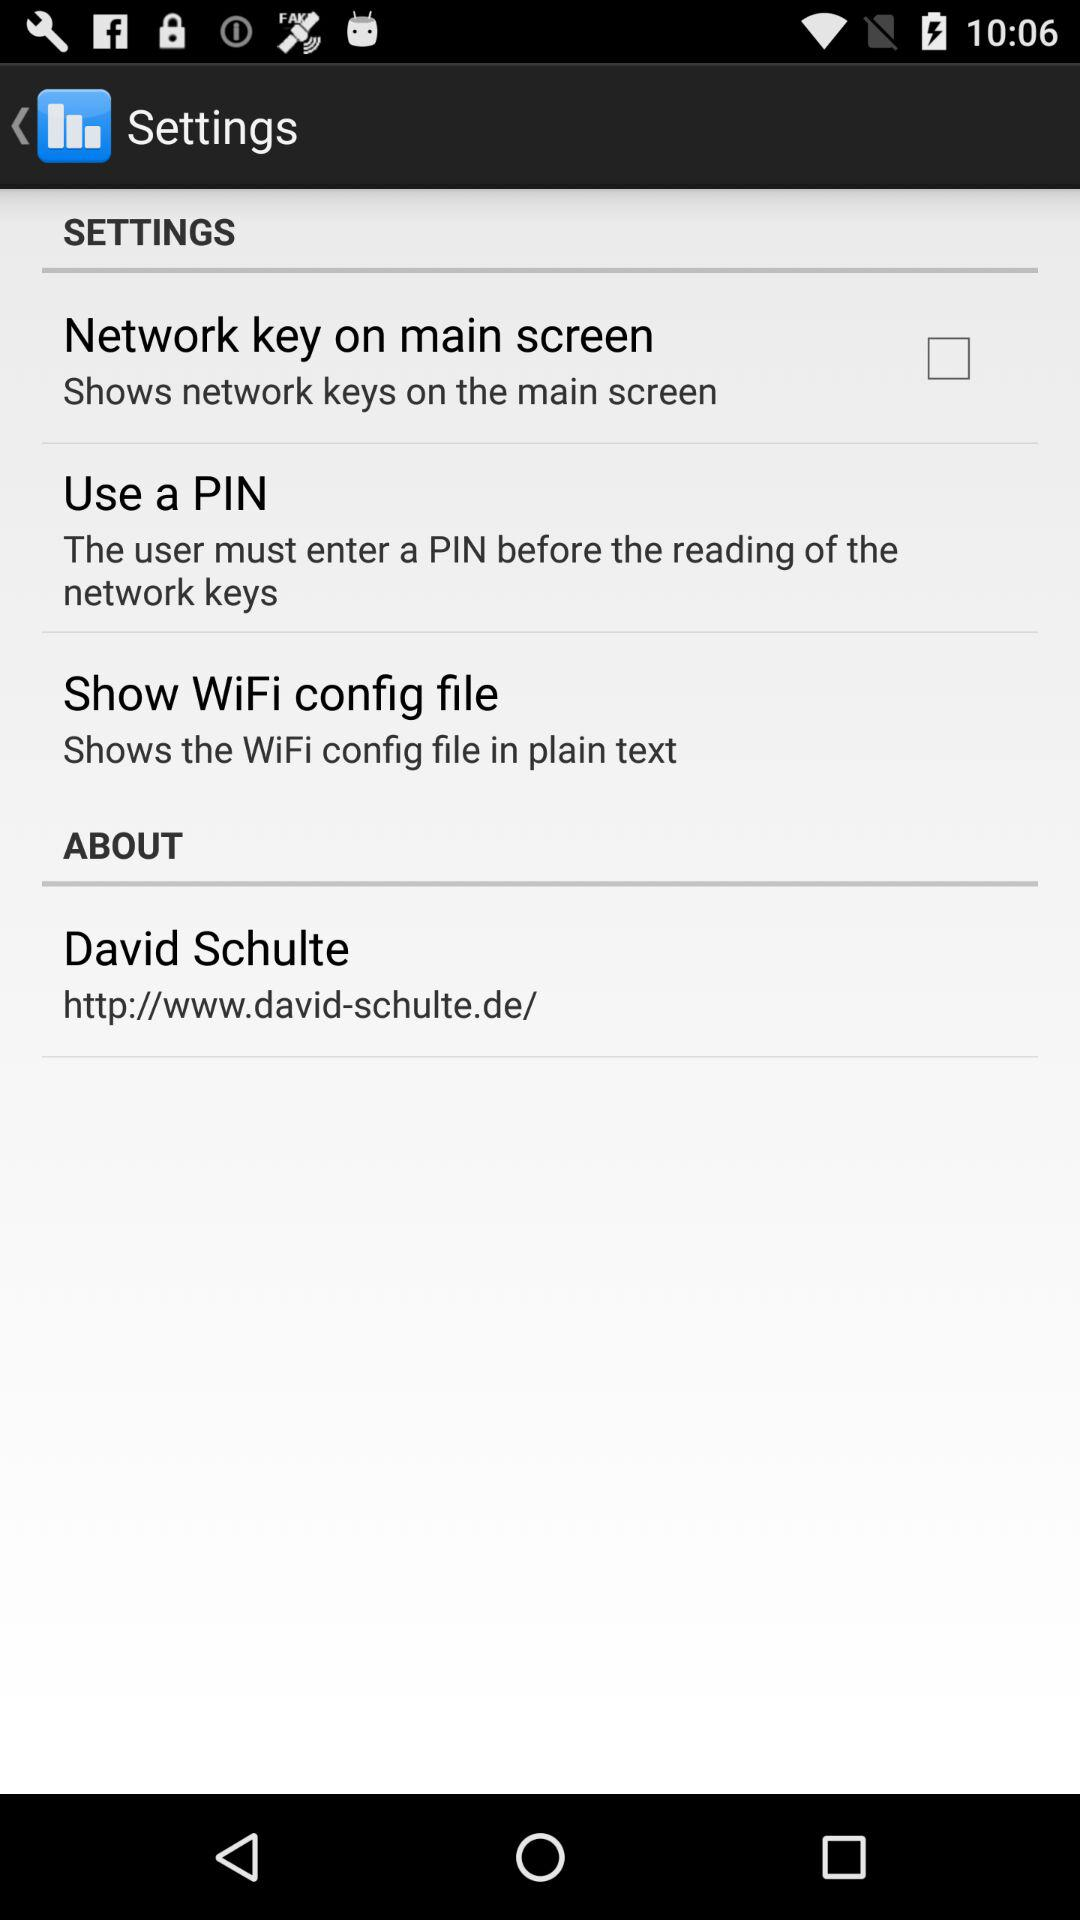What is the URL address for "David Schulte"? The URL address is "http://www.david-schulte.de/". 